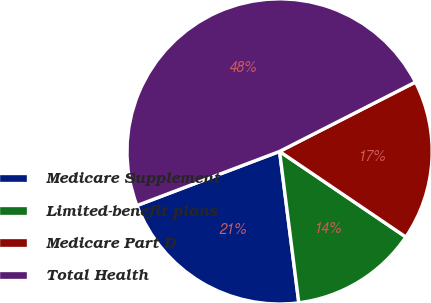Convert chart to OTSL. <chart><loc_0><loc_0><loc_500><loc_500><pie_chart><fcel>Medicare Supplement<fcel>Limited-benefit plans<fcel>Medicare Part D<fcel>Total Health<nl><fcel>21.24%<fcel>13.51%<fcel>16.99%<fcel>48.26%<nl></chart> 